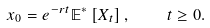Convert formula to latex. <formula><loc_0><loc_0><loc_500><loc_500>x _ { 0 } = e ^ { - r t } \mathbb { E } ^ { * } \left [ X _ { t } \right ] , \quad t \geq 0 .</formula> 